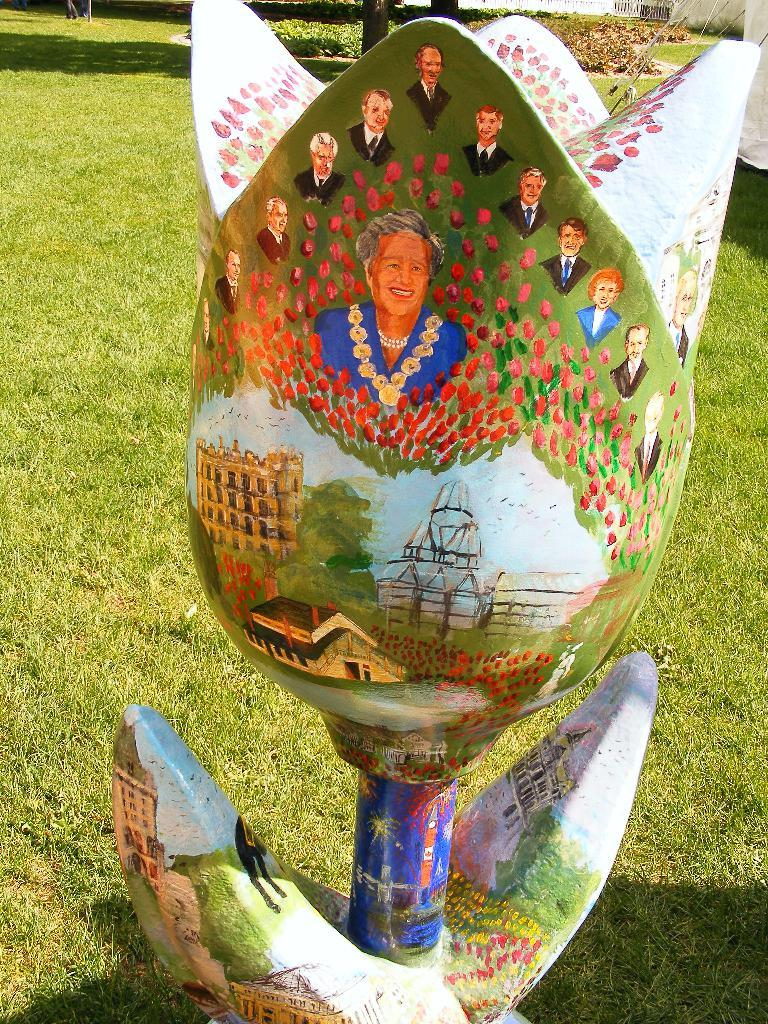What type of object is present in the image that is not a natural flower? There is an artificial flower in the image. What is unique about the artificial flower? The artificial flower has a painting on it. What else can be seen in the image besides the artificial flower? There are pictures of people and green grass at the bottom of the image. What type of vegetation is visible in the background of the image? There are plants in the background of the image. Where is the stove located in the image? There is no stove present in the image. What type of straw is used to create the artificial flower? The artificial flower in the image is not made of straw; it is made of other materials. 